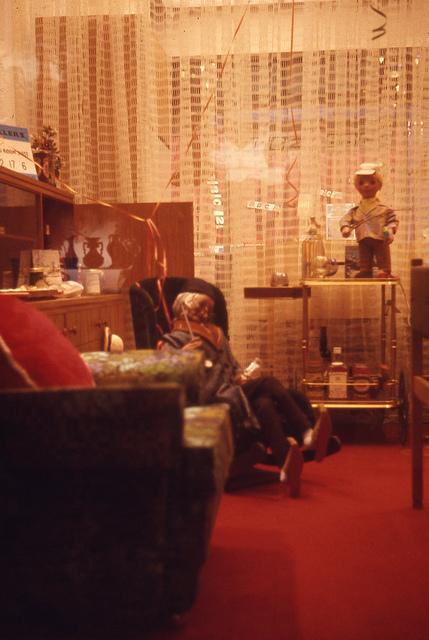Are there knick knacks in the image?
Answer briefly. Yes. What color is the carpet?
Give a very brief answer. Red. What is standing on the table by the window?
Short answer required. Doll. 